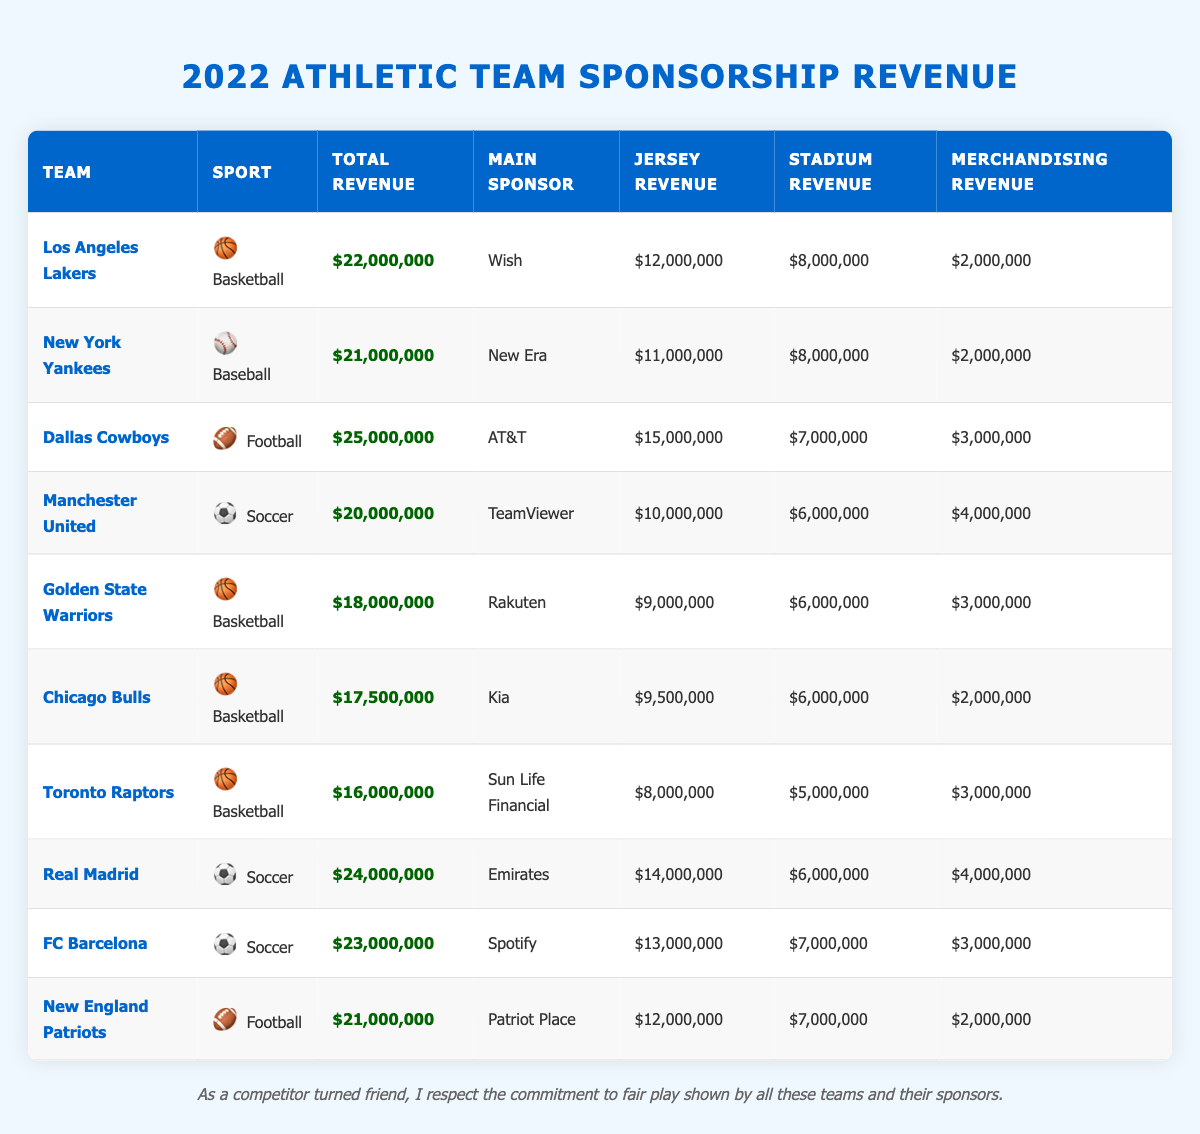What is the total sponsorship revenue for the Dallas Cowboys? The table lists the Dallas Cowboys with a total sponsorship revenue of $25,000,000.
Answer: $25,000,000 Which team has the highest sponsorship revenue? The Dallas Cowboys have the highest sponsorship revenue at $25,000,000, which is greater than all other teams listed.
Answer: Dallas Cowboys What is the main sponsor for the Los Angeles Lakers? The table indicates that the main sponsor for the Los Angeles Lakers is Wish.
Answer: Wish How much revenue did the New York Yankees generate from jersey sponsorships? The New York Yankees generated $11,000,000 from jersey sponsorships according to the table.
Answer: $11,000,000 What is the total merchandising revenue for Real Madrid and FC Barcelona combined? Real Madrid has merchandising revenue of $4,000,000, and FC Barcelona has $3,000,000. Together, they sum up to $7,000,000.
Answer: $7,000,000 Which sport generated the least total revenue among the teams listed? The Toronto Raptors, with a total revenue of $16,000,000, generated the least total revenue among the teams in the table.
Answer: Basketball Is the main sponsor for the Chicago Bulls Kia? Yes, the table confirms that the main sponsor for the Chicago Bulls is indeed Kia.
Answer: Yes What is the average sponsorship revenue for football teams? The football teams listed are the Dallas Cowboys ($25,000,000), New England Patriots ($21,000,000), summing up to $46,000,000. There are 2 football teams, so the average is $46,000,000 / 2 = $23,000,000.
Answer: $23,000,000 Which team has the highest revenue from jersey sponsorships? The Dallas Cowboys have the highest revenue from jersey sponsorships at $15,000,000, compared to others listed.
Answer: Dallas Cowboys If we combine the stadium revenue from the Golden State Warriors and the Chicago Bulls, what would be the total? The Golden State Warriors' stadium revenue is $6,000,000 and the Chicago Bulls' stadium revenue is also $6,000,000. The total is $6,000,000 + $6,000,000 = $12,000,000.
Answer: $12,000,000 